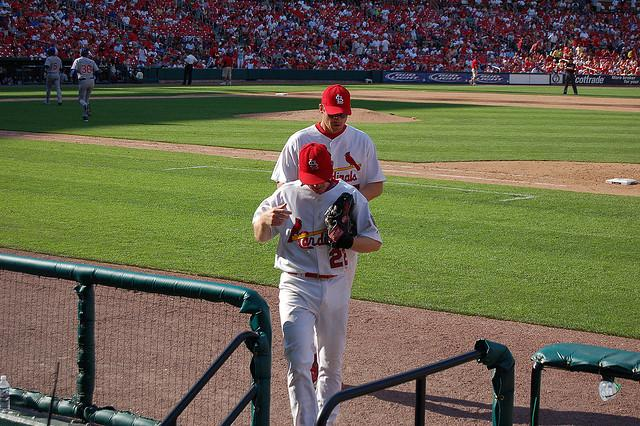At which location are the Cardinals playing? Please explain your reasoning. home field. The baseball team is at home as seen by all the fans in red. 